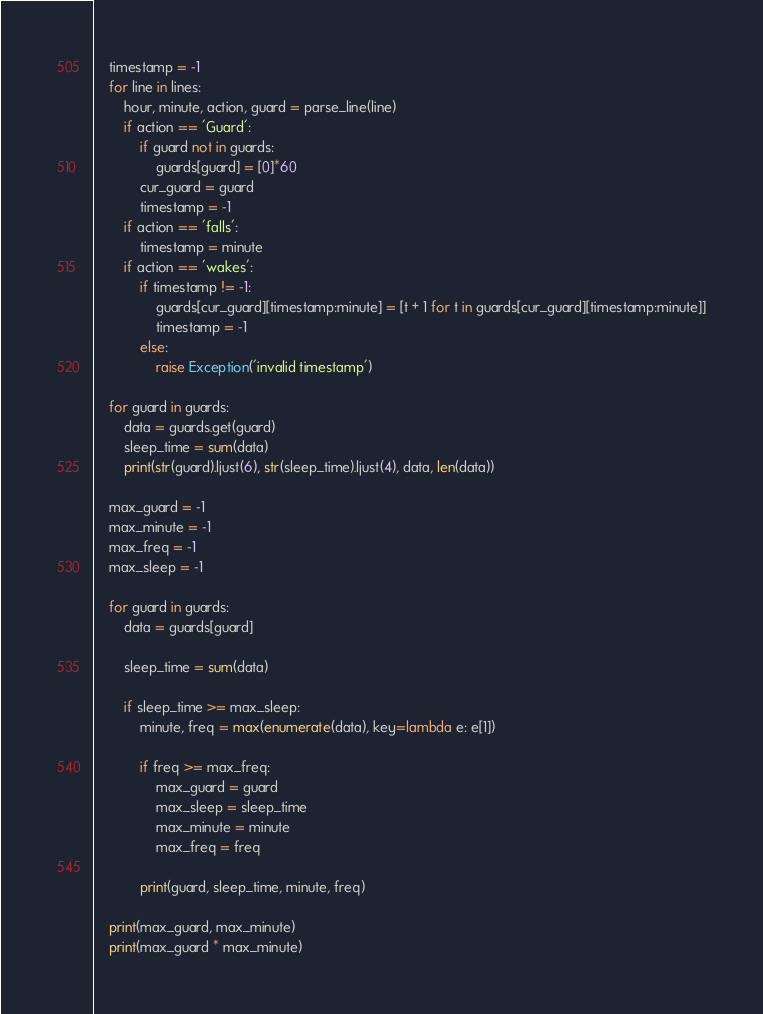Convert code to text. <code><loc_0><loc_0><loc_500><loc_500><_Python_>    timestamp = -1
    for line in lines:
        hour, minute, action, guard = parse_line(line)
        if action == 'Guard':
            if guard not in guards:
                guards[guard] = [0]*60
            cur_guard = guard
            timestamp = -1
        if action == 'falls':
            timestamp = minute
        if action == 'wakes':
            if timestamp != -1:
                guards[cur_guard][timestamp:minute] = [t + 1 for t in guards[cur_guard][timestamp:minute]]
                timestamp = -1
            else:
                raise Exception('invalid timestamp')

    for guard in guards:
        data = guards.get(guard)
        sleep_time = sum(data)
        print(str(guard).ljust(6), str(sleep_time).ljust(4), data, len(data))

    max_guard = -1
    max_minute = -1
    max_freq = -1
    max_sleep = -1

    for guard in guards:
        data = guards[guard]

        sleep_time = sum(data)

        if sleep_time >= max_sleep:
            minute, freq = max(enumerate(data), key=lambda e: e[1])

            if freq >= max_freq:
                max_guard = guard
                max_sleep = sleep_time
                max_minute = minute
                max_freq = freq

            print(guard, sleep_time, minute, freq)

    print(max_guard, max_minute)
    print(max_guard * max_minute)
</code> 